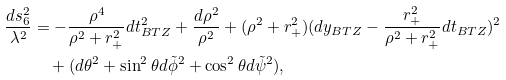<formula> <loc_0><loc_0><loc_500><loc_500>\frac { d s _ { 6 } ^ { 2 } } { \lambda ^ { 2 } } & = - \frac { \rho ^ { 4 } } { \rho ^ { 2 } + r _ { + } ^ { 2 } } d t _ { B T Z } ^ { 2 } + \frac { d \rho ^ { 2 } } { \rho ^ { 2 } } + ( \rho ^ { 2 } + r _ { + } ^ { 2 } ) ( d y _ { B T Z } - \frac { r _ { + } ^ { 2 } } { \rho ^ { 2 } + r _ { + } ^ { 2 } } d t _ { B T Z } ) ^ { 2 } \\ & \quad + ( d \theta ^ { 2 } + \sin ^ { 2 } \theta d \tilde { \phi } ^ { 2 } + \cos ^ { 2 } \theta d \tilde { \psi } ^ { 2 } ) ,</formula> 